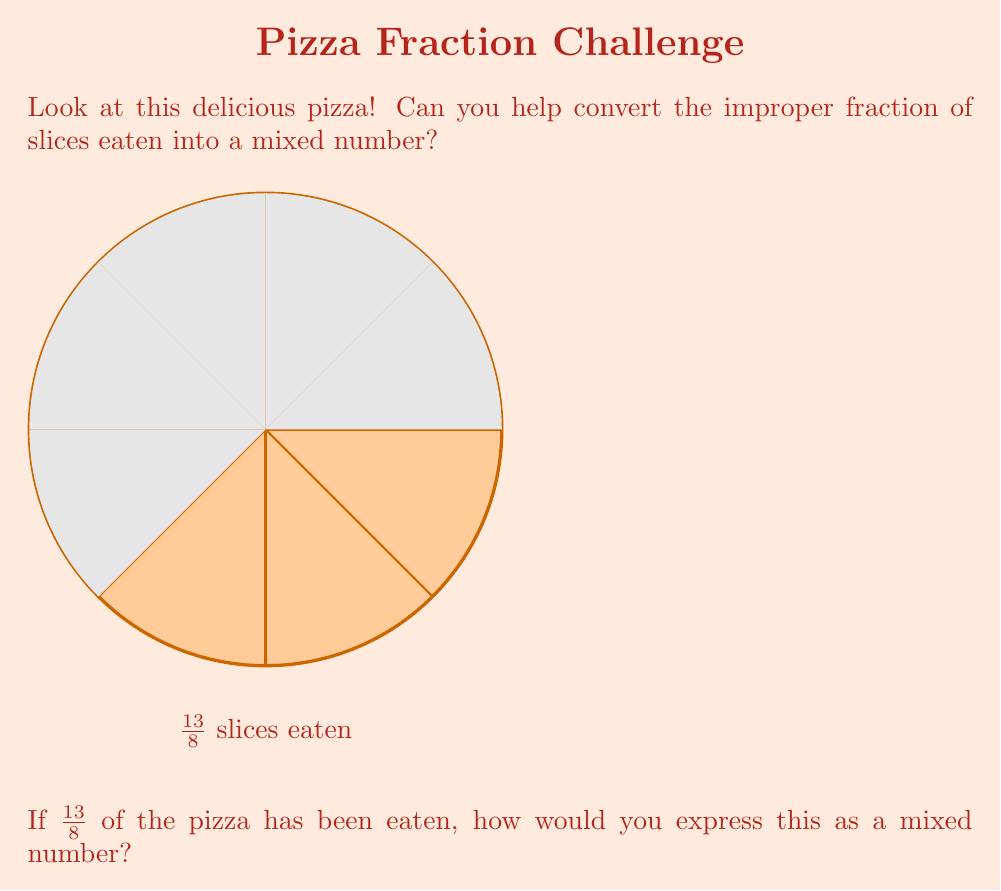Can you solve this math problem? Let's break this down step-by-step:

1) To convert an improper fraction to a mixed number, we need to divide the numerator by the denominator:

   $13 \div 8 = 1$ remainder $5$

2) The quotient (1) becomes the whole number part of our mixed number.

3) The remainder (5) becomes the numerator of the fractional part, and the denominator (8) stays the same.

4) So, we can write this as:

   $\frac{13}{8} = 1\frac{5}{8}$

This means 1 whole pizza and $\frac{5}{8}$ of another pizza have been eaten.

5) Let's check: 
   $1\frac{5}{8} = 1 + \frac{5}{8} = \frac{8}{8} + \frac{5}{8} = \frac{13}{8}$

So, our conversion is correct!
Answer: $1\frac{5}{8}$ 